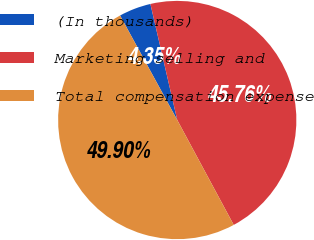Convert chart to OTSL. <chart><loc_0><loc_0><loc_500><loc_500><pie_chart><fcel>(In thousands)<fcel>Marketing selling and<fcel>Total compensation expense<nl><fcel>4.35%<fcel>45.76%<fcel>49.9%<nl></chart> 